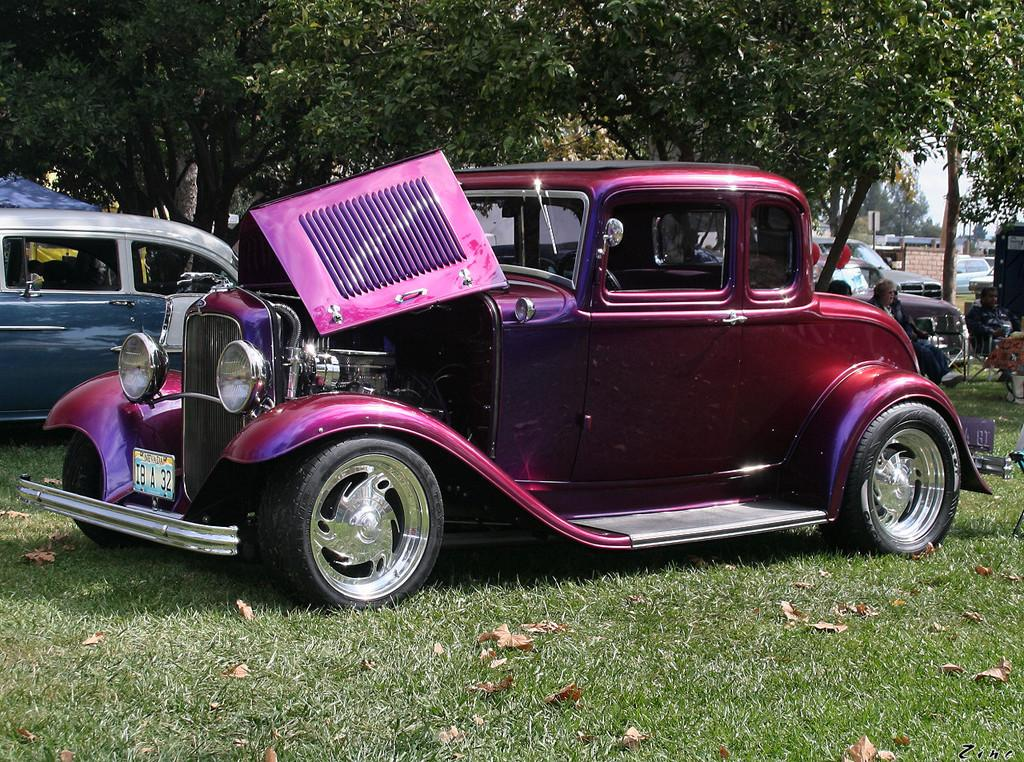What types of objects are present in the image? There are vehicles, chairs, grass, trees, and other objects in the image. Can you describe the setting of the image? The image features a grassy area with trees, and the sky is visible in the background. How many people are in the image? Two persons are sitting on chairs in the image. What is the condition of the sky in the image? The sky is visible in the background of the image. What type of plastic material is being used to say good-bye in the image? There is no plastic material or good-bye scene present in the image. What scene is being depicted in the image? The image features a grassy area with trees, vehicles, chairs, and people sitting on the chairs. 